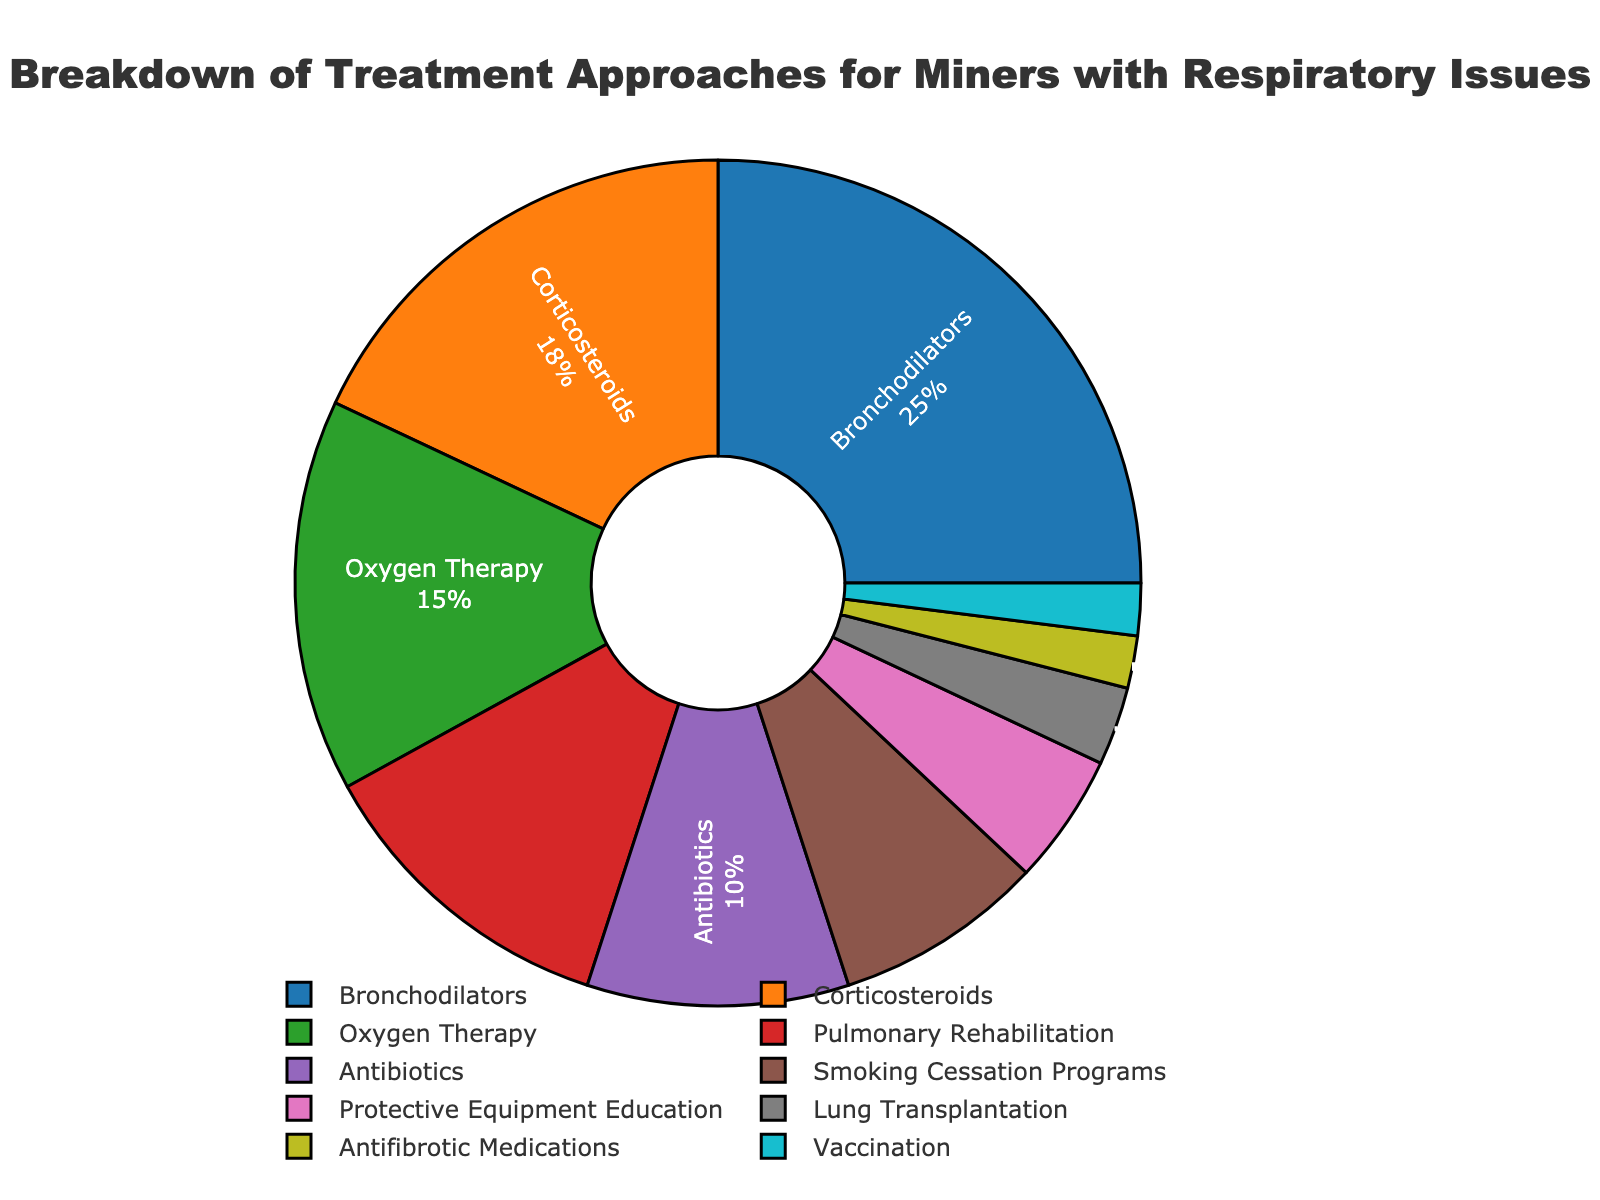Which treatment approach is used the most? By observing the size of each section of the pie chart, we can see that "Bronchodilators" occupies the largest portion.
Answer: Bronchodilators How much more common is the use of Bronchodilators compared to Corticosteroids? The percentage for Bronchodilators is 25%, and for Corticosteroids, it's 18%. Subtracting these values gives us 25% - 18% = 7%.
Answer: 7% What is the combined percentage of treatments that are less prevalent than Pulmonary Rehabilitation? Pulmonary Rehabilitation has a 12% share. Treatments with a lower percentage are Antibiotics (10%), Smoking Cessation Programs (8%), Protective Equipment Education (5%), Lung Transplantation (3%), Antifibrotic Medications (2%), and Vaccination (2%). Adding these gives 10% + 8% + 5% + 3% + 2% + 2% = 30%.
Answer: 30% Which treatment approach is represented by the color green? By referring to the provided color assignments, "Oxygen Therapy" is represented by the green section.
Answer: Oxygen Therapy Is the percentage of Antibiotics usage more than the sum of Lung Transplantation and Antifibrotic Medications? The percentage for Antibiotics is 10%. Lung Transplantation is 3%, and Antifibrotic Medications are 2%. The sum of Lung Transplantation and Antifibrotic Medications is 3% + 2% = 5%. 10% is greater than 5%.
Answer: Yes What is the difference in percentage between Pulmonary Rehabilitation and Smoking Cessation Programs? Pulmonary Rehabilitation holds 12%, while Smoking Cessation Programs are at 8%. The difference is 12% - 8% = 4%.
Answer: 4% Which treatment approach has the least representation, and what is its percentage? The smallest sections of the pie chart represent "Antifibrotic Medications" and "Vaccination," both at 2%.
Answer: Antifibrotic Medications and Vaccination, 2% What percentage of treatments involve education or programs (e.g., Smoking Cessation Programs, Protective Equipment Education)? Adding the percentages for Smoking Cessation Programs (8%) and Protective Equipment Education (5%) gives 8% + 5% = 13%.
Answer: 13% How much more common are Corticosteroids compared to the combined percentage of Antifibrotic Medications and Vaccination? Corticosteroids make up 18%. Antifibrotic Medications and Vaccination combined total 2% + 2% = 4%. Therefore, the difference is 18% - 4% = 14%.
Answer: 14% 